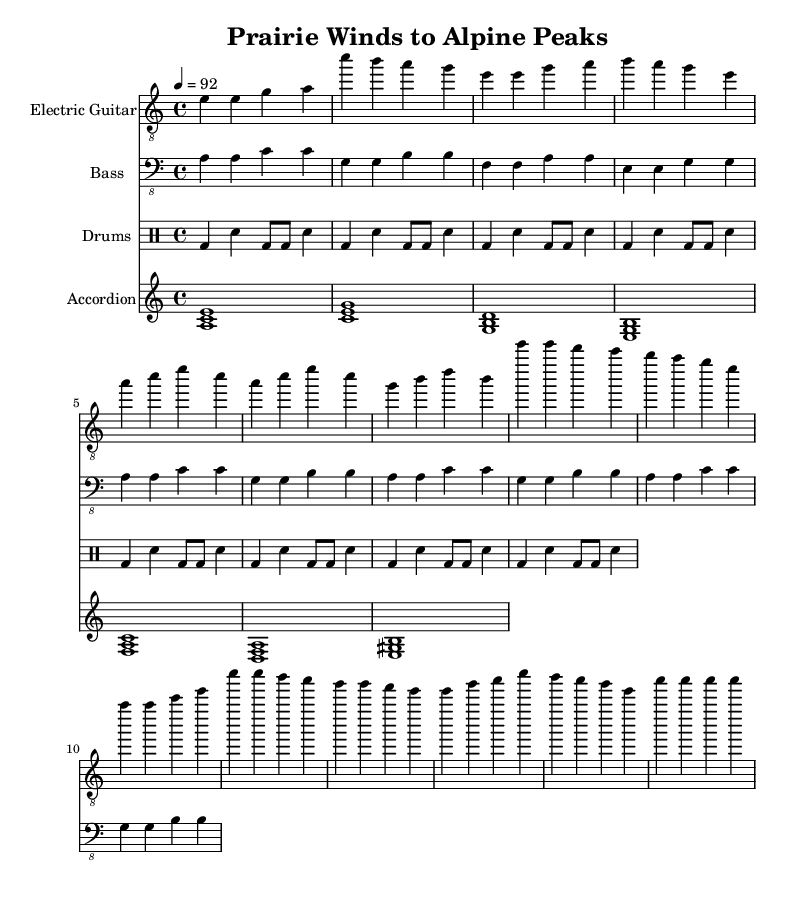What is the key signature of this music? The key signature is A minor, which contains no sharps or flats. Minor keys typically share their key signature with their relative major, which in this case is C major.
Answer: A minor What is the time signature of this music? The time signature is 4/4, which means there are four beats in each measure and the quarter note gets one beat. This is common in blues music.
Answer: 4/4 What is the tempo marking for this music? The tempo marking is 92 beats per minute, indicated by the tempo notation at the beginning of the score. This adds to the feel of the piece being a moderate blues tempo.
Answer: 92 How many measures are in the intro? The intro consists of four measures, identifiable from the notation that provides the initial thematic material before the verse starts.
Answer: 4 What instruments are featured in this piece? The instruments present in this piece include Electric Guitar, Bass, Drums, and Accordion. Each is notated on separate staves.
Answer: Electric Guitar, Bass, Drums, Accordion What is the form of this composition? The composition has an introspective form consisting of an intro, verse, chorus, bridge, and outro, typical structures found in blues music that create contrast and development.
Answer: Intro, Verse, Chorus, Bridge, Outro How does the bass line relate to the key signature? The bass line predominantly features the notes A, C, G, and E, which are chord tones in the key of A minor, connecting directly to the harmonic structure of the piece and supporting the overall tonality.
Answer: A, C, G, E 